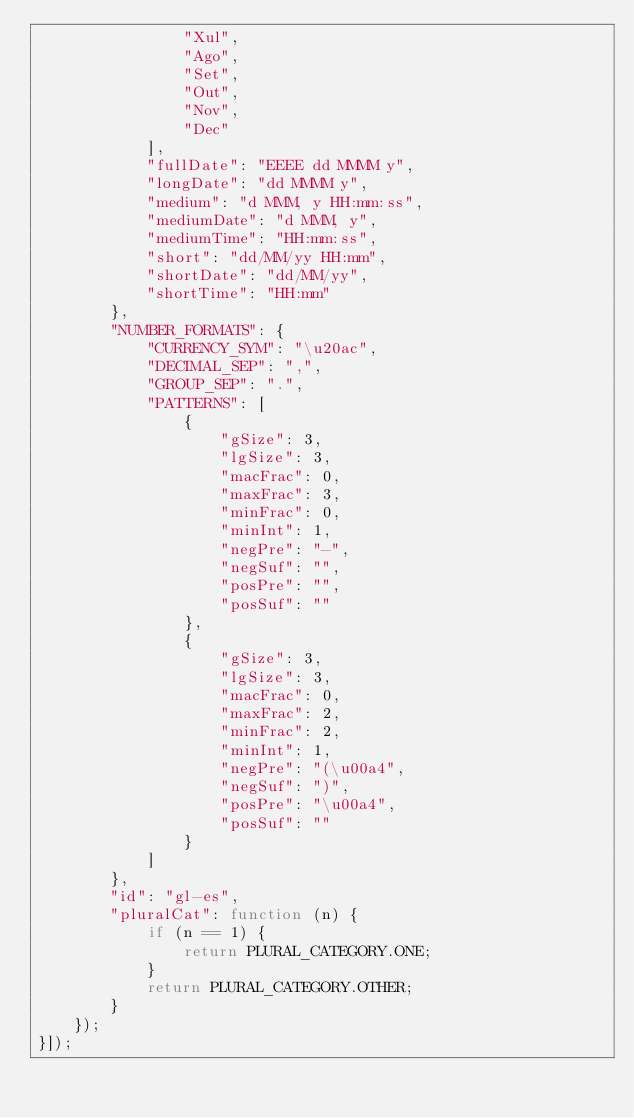Convert code to text. <code><loc_0><loc_0><loc_500><loc_500><_JavaScript_>                "Xul",
                "Ago",
                "Set",
                "Out",
                "Nov",
                "Dec"
            ],
            "fullDate": "EEEE dd MMMM y",
            "longDate": "dd MMMM y",
            "medium": "d MMM, y HH:mm:ss",
            "mediumDate": "d MMM, y",
            "mediumTime": "HH:mm:ss",
            "short": "dd/MM/yy HH:mm",
            "shortDate": "dd/MM/yy",
            "shortTime": "HH:mm"
        },
        "NUMBER_FORMATS": {
            "CURRENCY_SYM": "\u20ac",
            "DECIMAL_SEP": ",",
            "GROUP_SEP": ".",
            "PATTERNS": [
                {
                    "gSize": 3,
                    "lgSize": 3,
                    "macFrac": 0,
                    "maxFrac": 3,
                    "minFrac": 0,
                    "minInt": 1,
                    "negPre": "-",
                    "negSuf": "",
                    "posPre": "",
                    "posSuf": ""
                },
                {
                    "gSize": 3,
                    "lgSize": 3,
                    "macFrac": 0,
                    "maxFrac": 2,
                    "minFrac": 2,
                    "minInt": 1,
                    "negPre": "(\u00a4",
                    "negSuf": ")",
                    "posPre": "\u00a4",
                    "posSuf": ""
                }
            ]
        },
        "id": "gl-es",
        "pluralCat": function (n) {
            if (n == 1) {
                return PLURAL_CATEGORY.ONE;
            }
            return PLURAL_CATEGORY.OTHER;
        }
    });
}]);</code> 